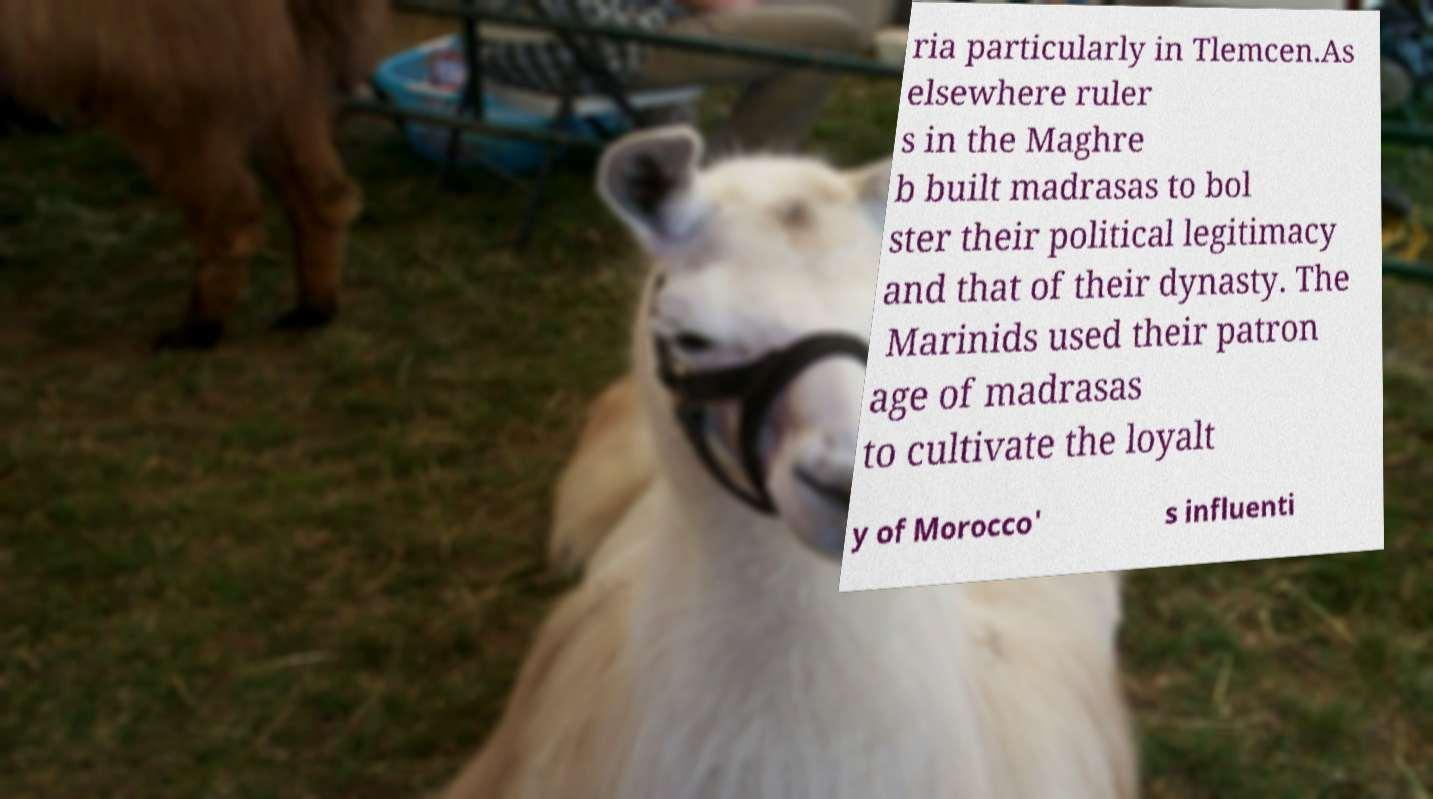There's text embedded in this image that I need extracted. Can you transcribe it verbatim? ria particularly in Tlemcen.As elsewhere ruler s in the Maghre b built madrasas to bol ster their political legitimacy and that of their dynasty. The Marinids used their patron age of madrasas to cultivate the loyalt y of Morocco' s influenti 